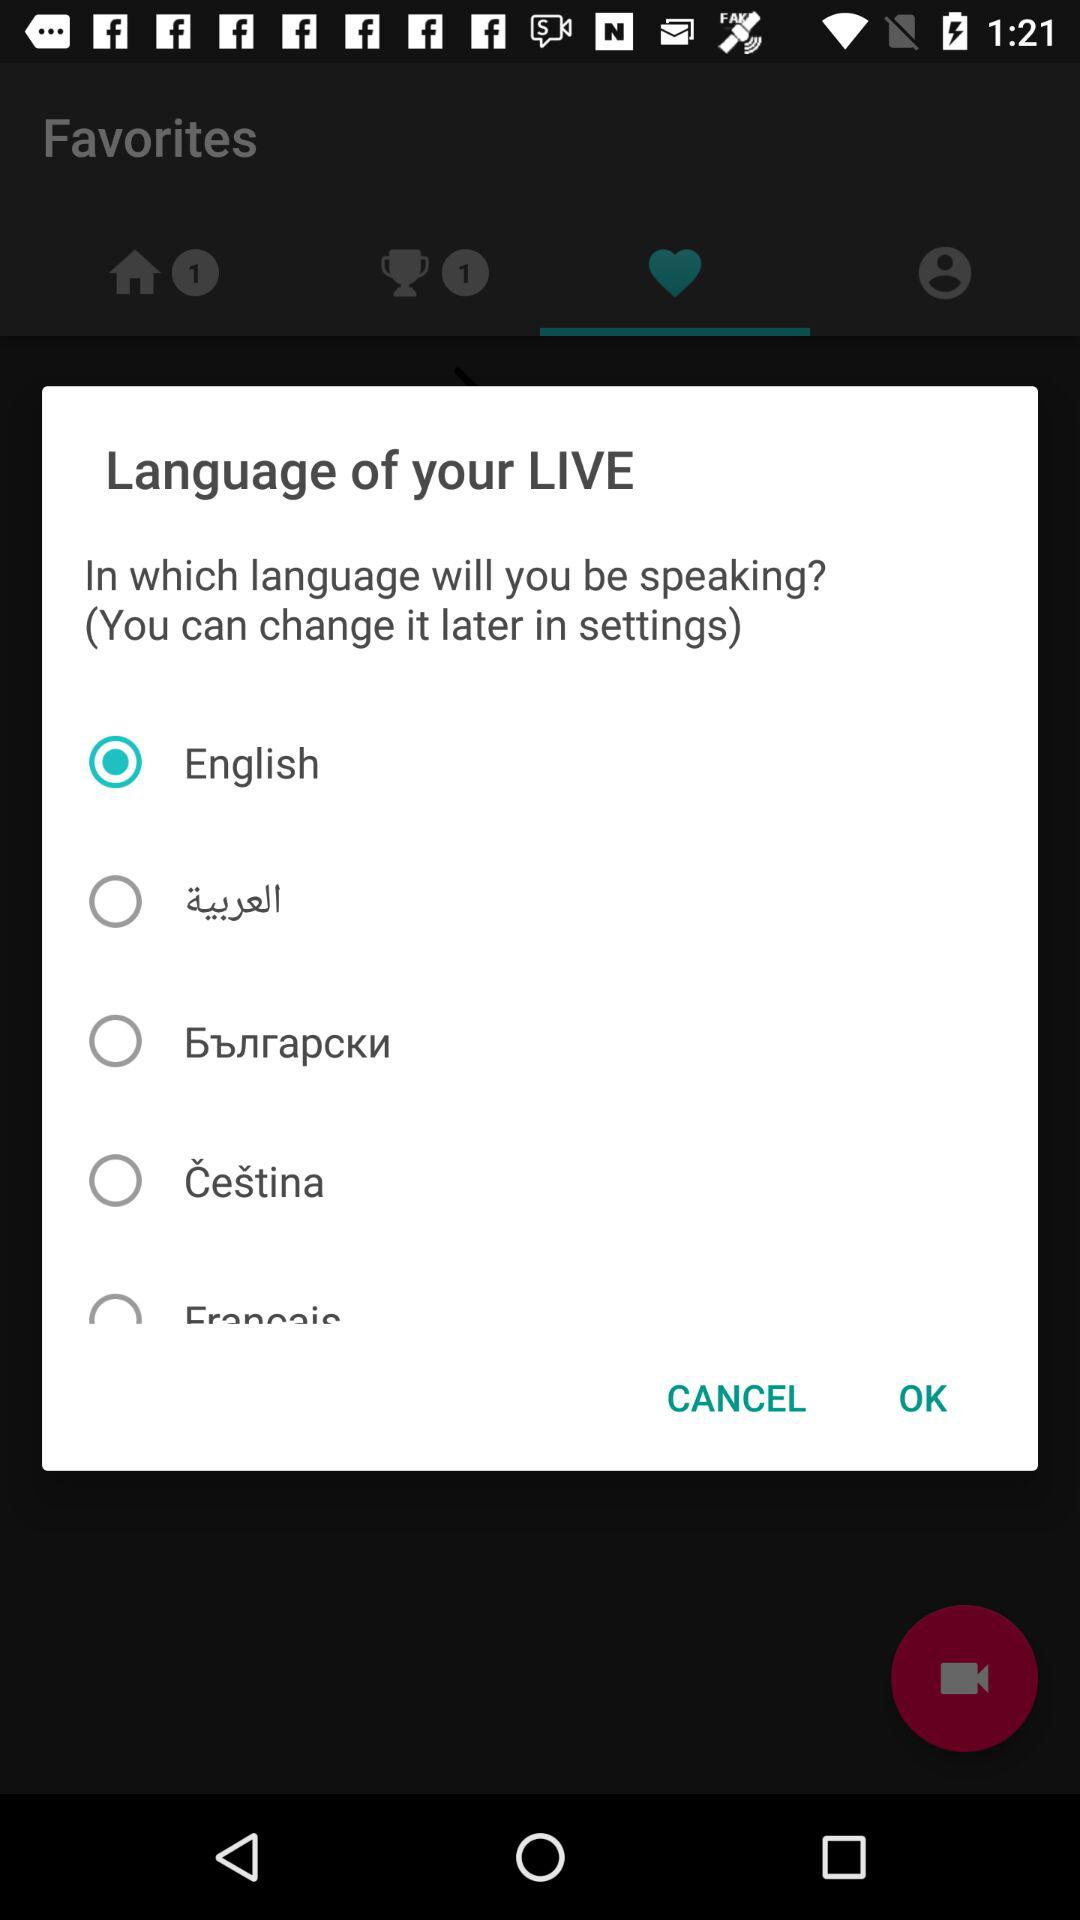How many languages are available to choose from?
Answer the question using a single word or phrase. 5 